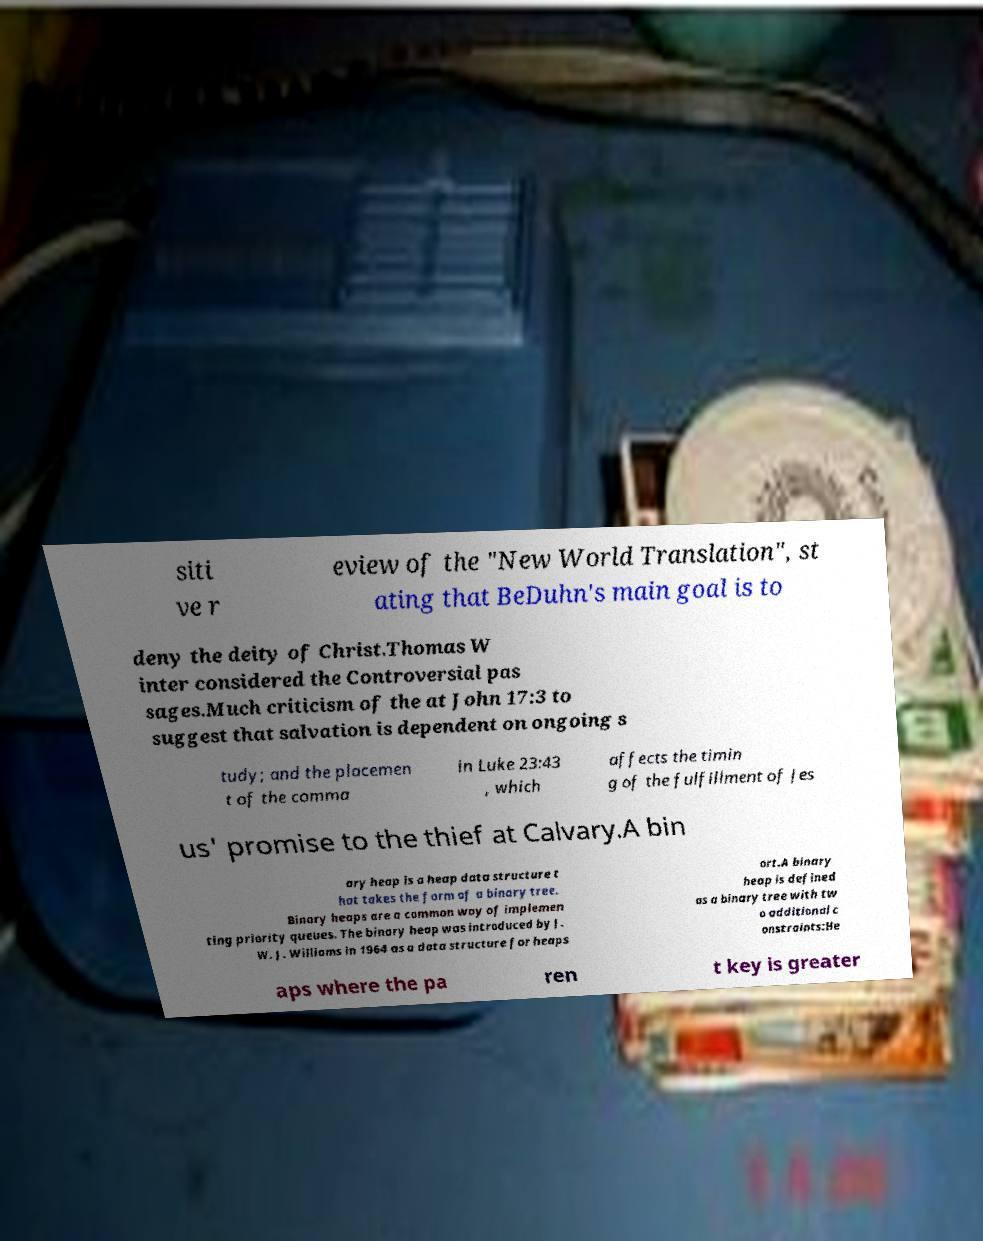Can you read and provide the text displayed in the image?This photo seems to have some interesting text. Can you extract and type it out for me? siti ve r eview of the "New World Translation", st ating that BeDuhn's main goal is to deny the deity of Christ.Thomas W inter considered the Controversial pas sages.Much criticism of the at John 17:3 to suggest that salvation is dependent on ongoing s tudy; and the placemen t of the comma in Luke 23:43 , which affects the timin g of the fulfillment of Jes us' promise to the thief at Calvary.A bin ary heap is a heap data structure t hat takes the form of a binary tree. Binary heaps are a common way of implemen ting priority queues. The binary heap was introduced by J. W. J. Williams in 1964 as a data structure for heaps ort.A binary heap is defined as a binary tree with tw o additional c onstraints:He aps where the pa ren t key is greater 